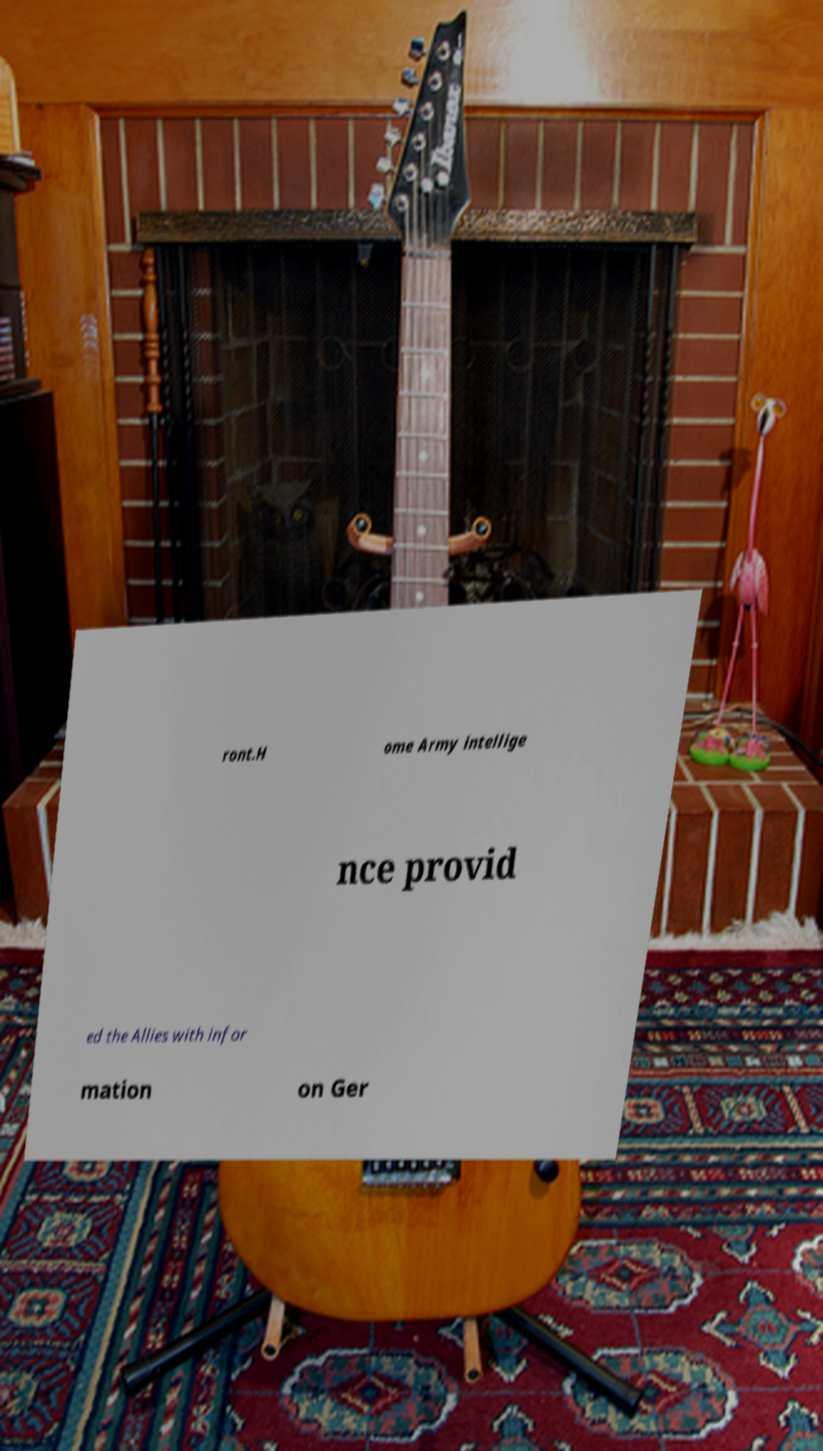For documentation purposes, I need the text within this image transcribed. Could you provide that? ront.H ome Army intellige nce provid ed the Allies with infor mation on Ger 